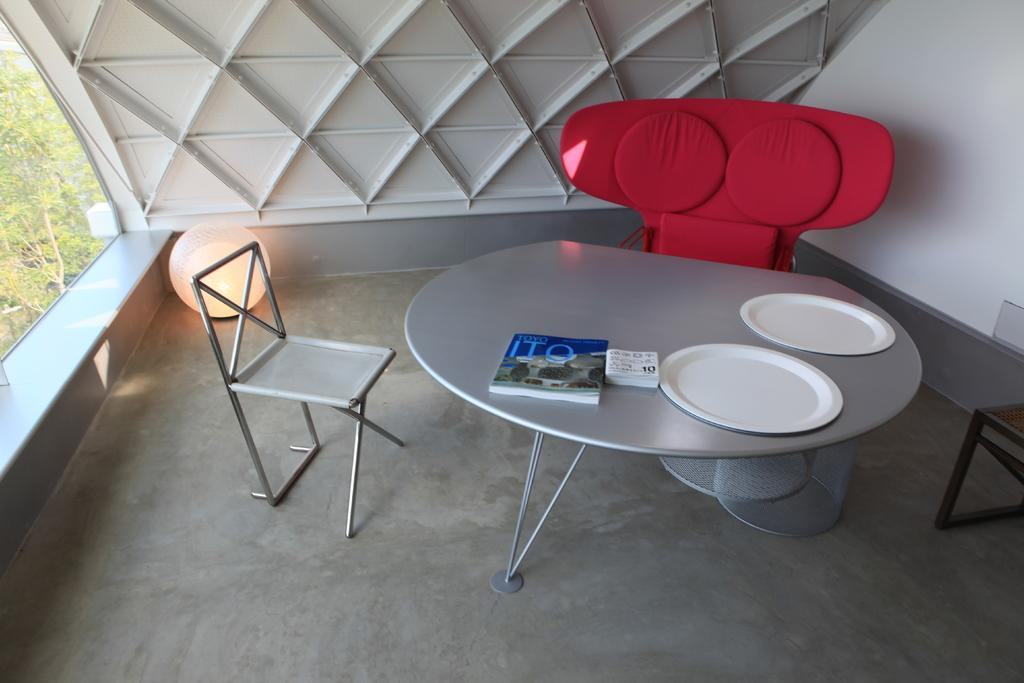What type of furniture is present in the image? There is a table and a chair in the image. What objects are on the table? There are books and plates on the table. What can be seen in the background of the image? There is a wall in the background of the image. What type of lighting is present in the image? There is a table lamp in the corner of the image. What is visible on the left side of the image? There are trees on the left side of the image. What type of soda is being served in the image? A: There is no soda present in the image; it features a table, chair, books, plates, a wall, a table lamp, and trees. 